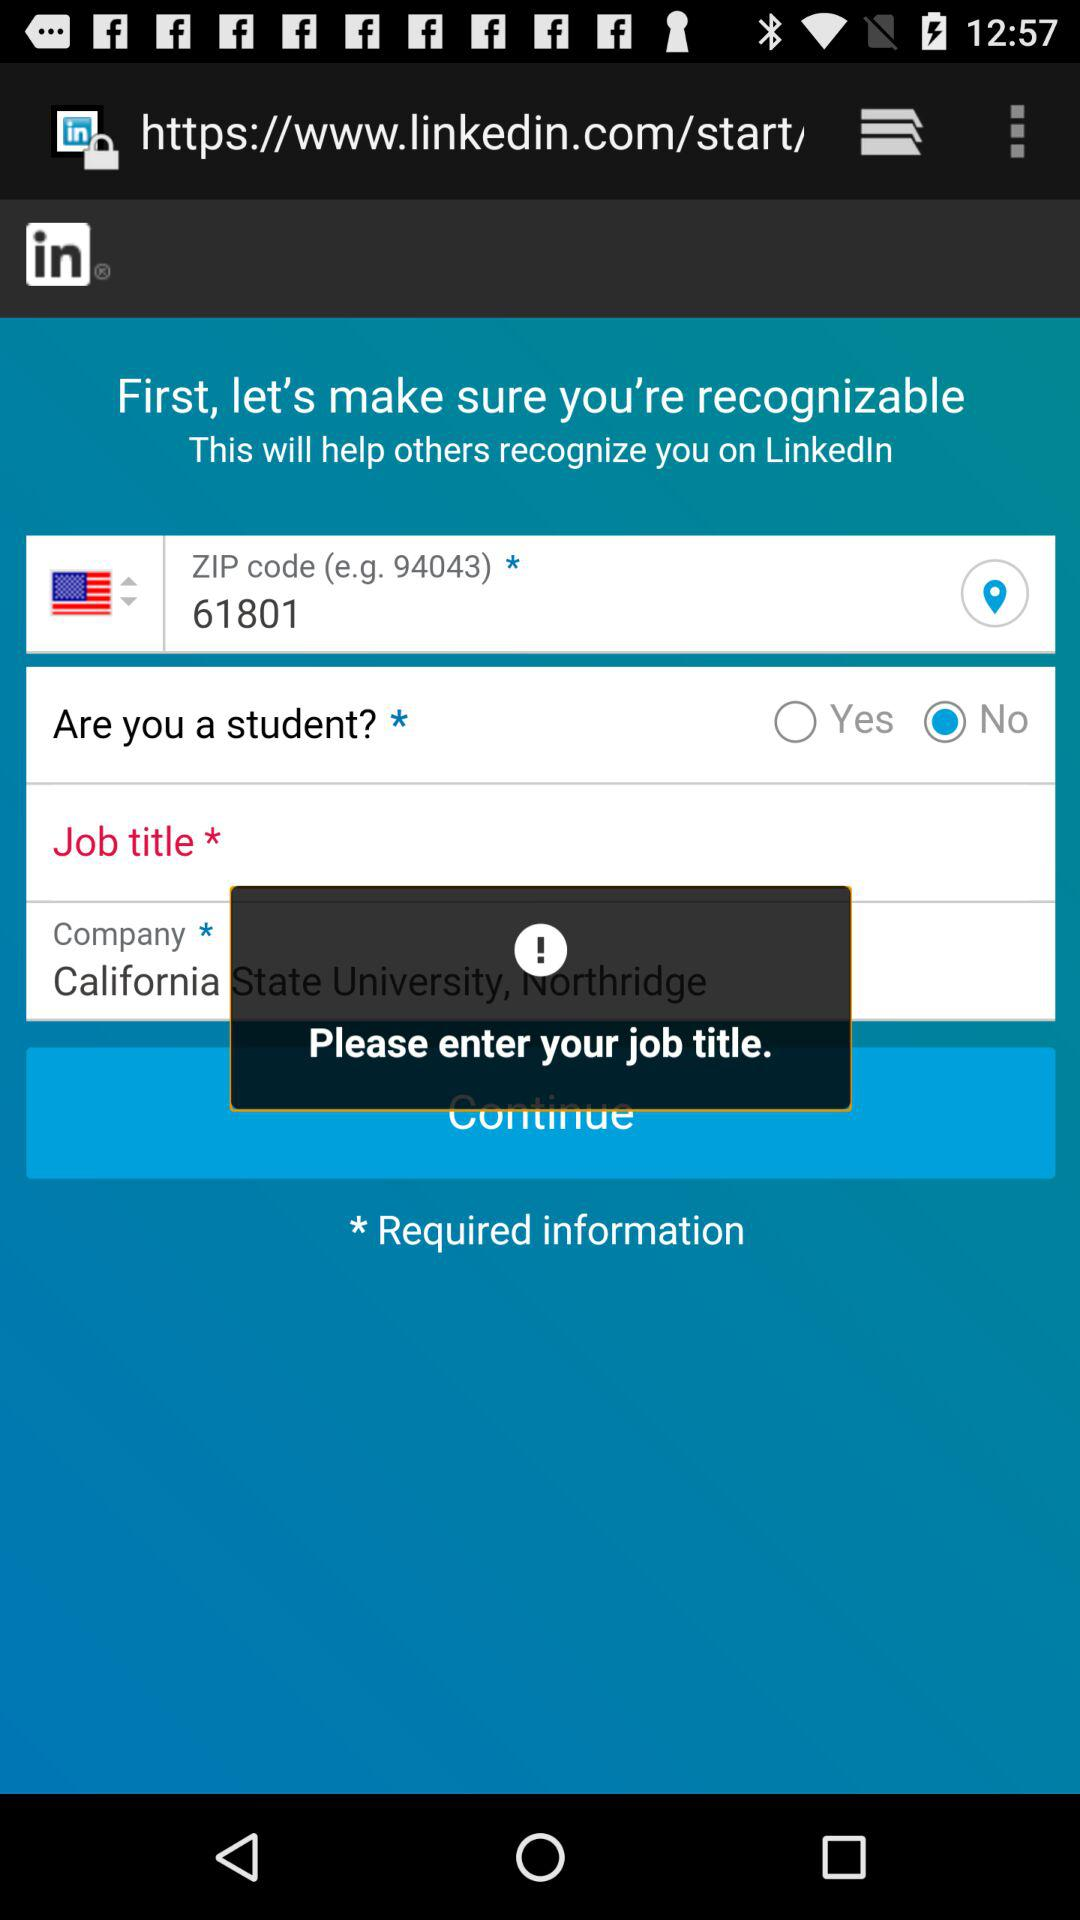What is the company name? The company name is "California State University, Northridge". 